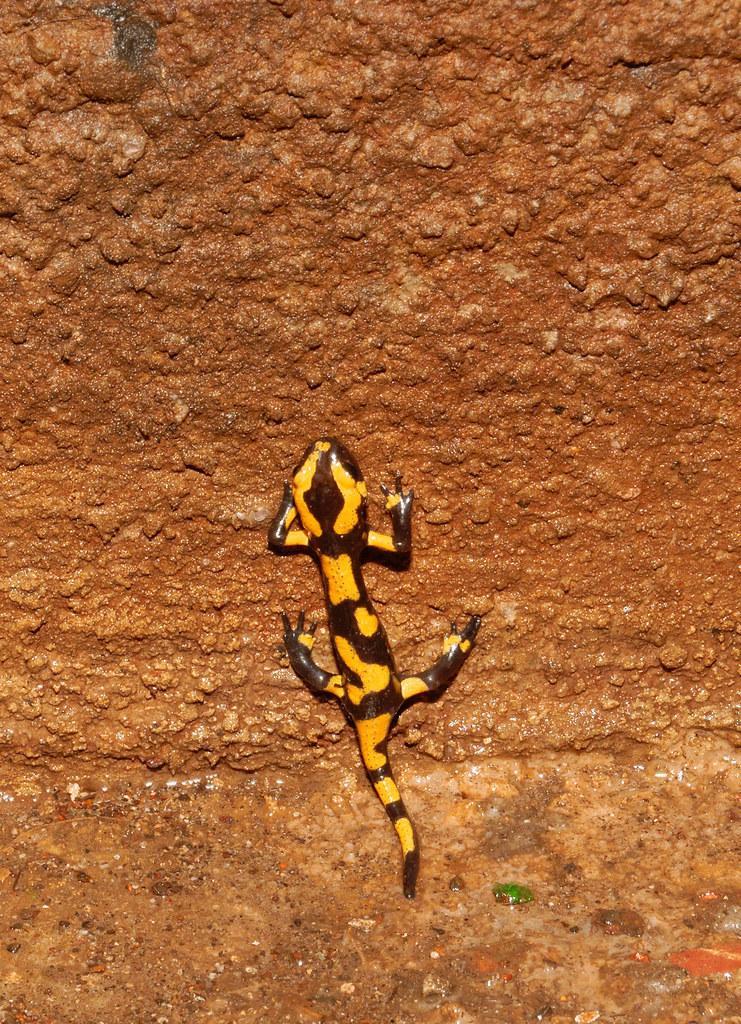Can you describe this image briefly? There is a lizard on the surface as we can see in the middle of this image. 